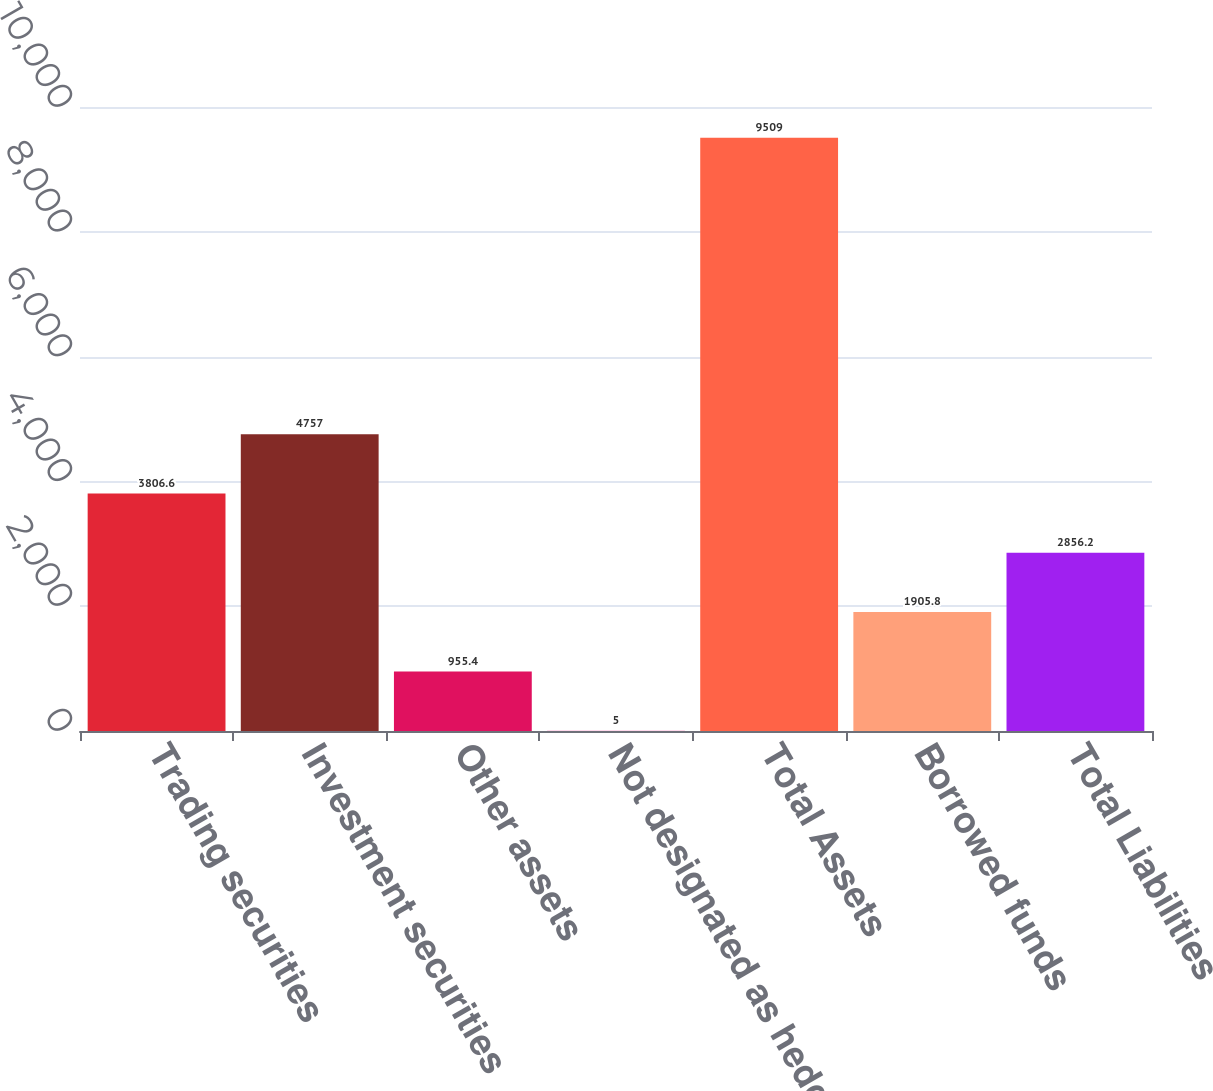<chart> <loc_0><loc_0><loc_500><loc_500><bar_chart><fcel>Trading securities<fcel>Investment securities<fcel>Other assets<fcel>Not designated as hedging<fcel>Total Assets<fcel>Borrowed funds<fcel>Total Liabilities<nl><fcel>3806.6<fcel>4757<fcel>955.4<fcel>5<fcel>9509<fcel>1905.8<fcel>2856.2<nl></chart> 